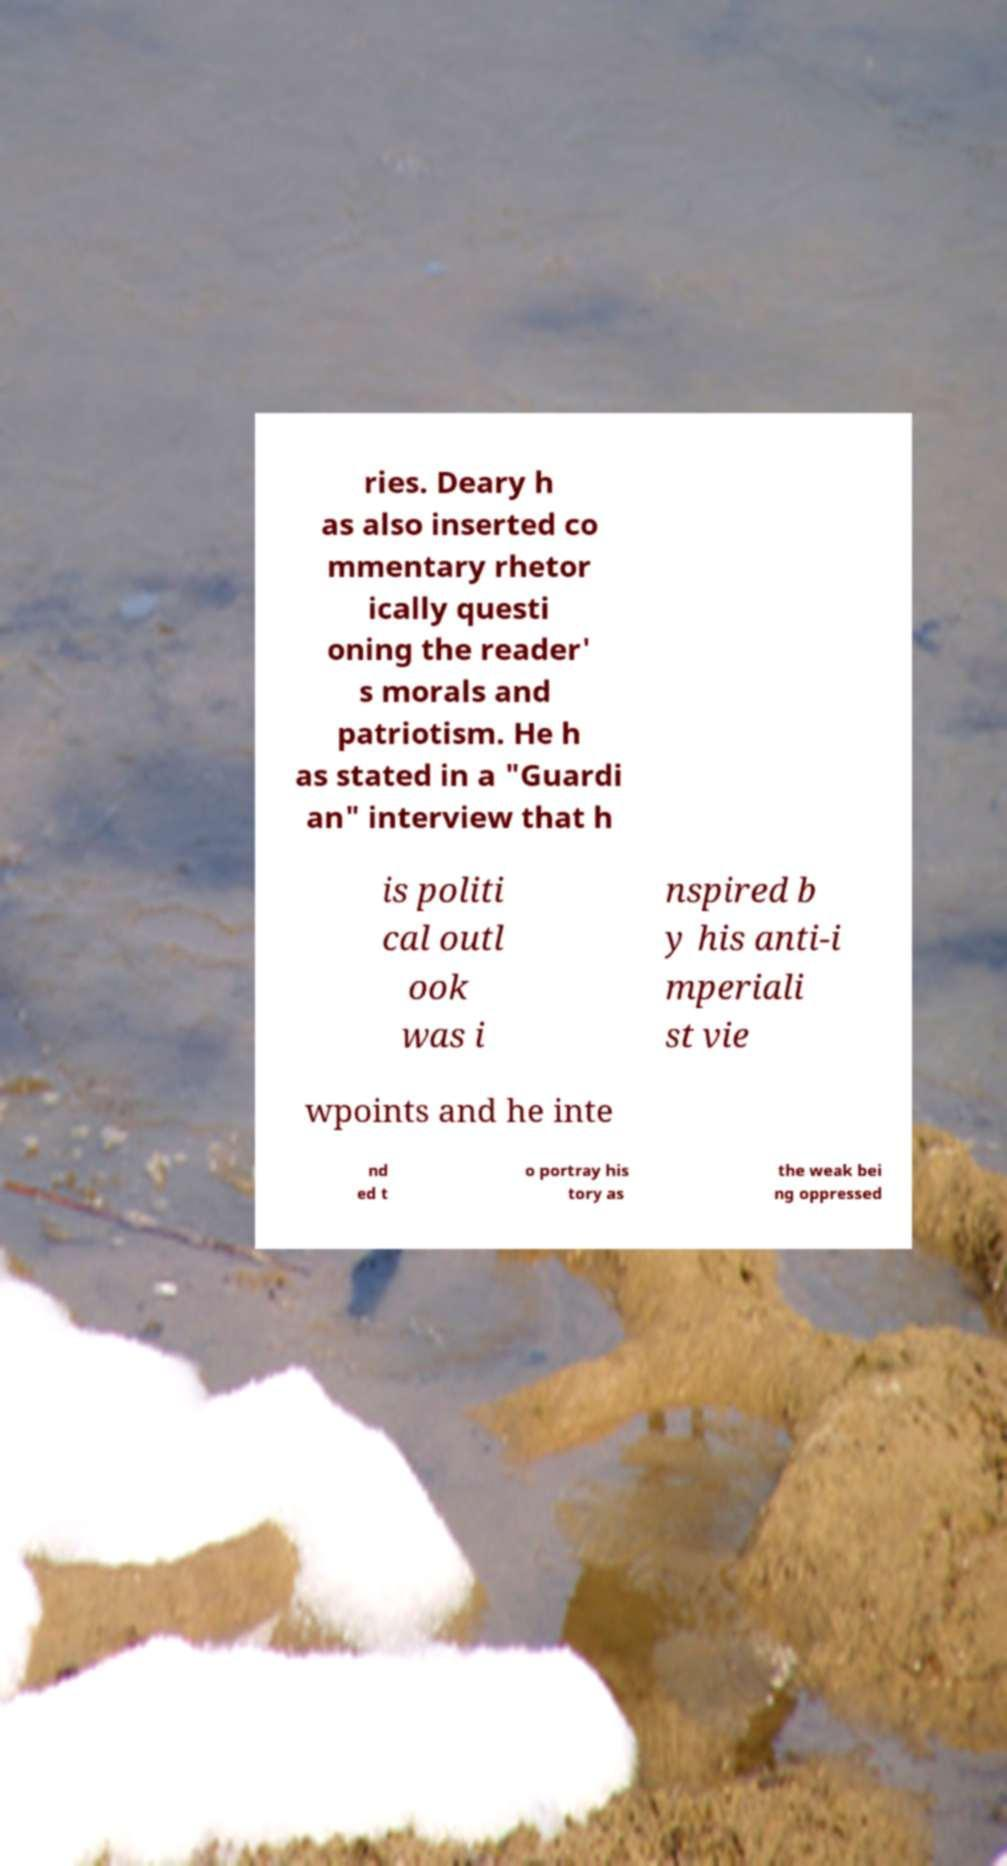Can you accurately transcribe the text from the provided image for me? ries. Deary h as also inserted co mmentary rhetor ically questi oning the reader' s morals and patriotism. He h as stated in a "Guardi an" interview that h is politi cal outl ook was i nspired b y his anti-i mperiali st vie wpoints and he inte nd ed t o portray his tory as the weak bei ng oppressed 